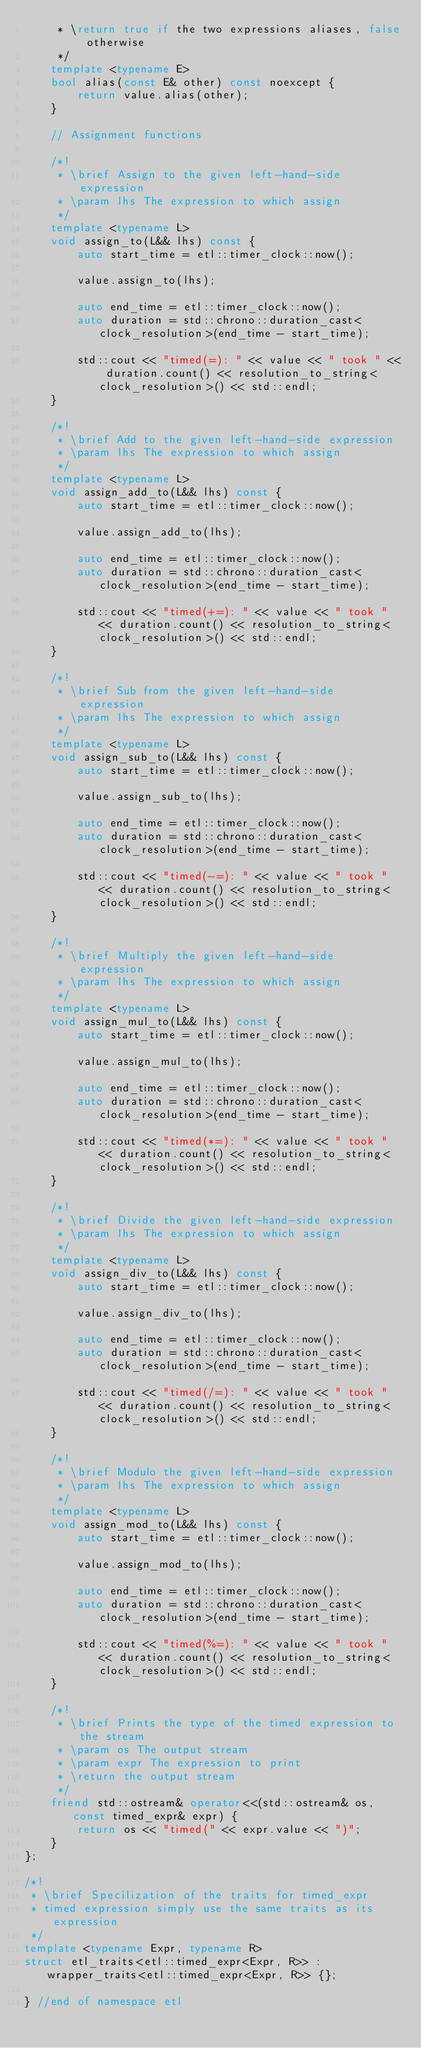Convert code to text. <code><loc_0><loc_0><loc_500><loc_500><_C++_>     * \return true if the two expressions aliases, false otherwise
     */
    template <typename E>
    bool alias(const E& other) const noexcept {
        return value.alias(other);
    }

    // Assignment functions

    /*!
     * \brief Assign to the given left-hand-side expression
     * \param lhs The expression to which assign
     */
    template <typename L>
    void assign_to(L&& lhs) const {
        auto start_time = etl::timer_clock::now();

        value.assign_to(lhs);

        auto end_time = etl::timer_clock::now();
        auto duration = std::chrono::duration_cast<clock_resolution>(end_time - start_time);

        std::cout << "timed(=): " << value << " took " << duration.count() << resolution_to_string<clock_resolution>() << std::endl;
    }

    /*!
     * \brief Add to the given left-hand-side expression
     * \param lhs The expression to which assign
     */
    template <typename L>
    void assign_add_to(L&& lhs) const {
        auto start_time = etl::timer_clock::now();

        value.assign_add_to(lhs);

        auto end_time = etl::timer_clock::now();
        auto duration = std::chrono::duration_cast<clock_resolution>(end_time - start_time);

        std::cout << "timed(+=): " << value << " took " << duration.count() << resolution_to_string<clock_resolution>() << std::endl;
    }

    /*!
     * \brief Sub from the given left-hand-side expression
     * \param lhs The expression to which assign
     */
    template <typename L>
    void assign_sub_to(L&& lhs) const {
        auto start_time = etl::timer_clock::now();

        value.assign_sub_to(lhs);

        auto end_time = etl::timer_clock::now();
        auto duration = std::chrono::duration_cast<clock_resolution>(end_time - start_time);

        std::cout << "timed(-=): " << value << " took " << duration.count() << resolution_to_string<clock_resolution>() << std::endl;
    }

    /*!
     * \brief Multiply the given left-hand-side expression
     * \param lhs The expression to which assign
     */
    template <typename L>
    void assign_mul_to(L&& lhs) const {
        auto start_time = etl::timer_clock::now();

        value.assign_mul_to(lhs);

        auto end_time = etl::timer_clock::now();
        auto duration = std::chrono::duration_cast<clock_resolution>(end_time - start_time);

        std::cout << "timed(*=): " << value << " took " << duration.count() << resolution_to_string<clock_resolution>() << std::endl;
    }

    /*!
     * \brief Divide the given left-hand-side expression
     * \param lhs The expression to which assign
     */
    template <typename L>
    void assign_div_to(L&& lhs) const {
        auto start_time = etl::timer_clock::now();

        value.assign_div_to(lhs);

        auto end_time = etl::timer_clock::now();
        auto duration = std::chrono::duration_cast<clock_resolution>(end_time - start_time);

        std::cout << "timed(/=): " << value << " took " << duration.count() << resolution_to_string<clock_resolution>() << std::endl;
    }

    /*!
     * \brief Modulo the given left-hand-side expression
     * \param lhs The expression to which assign
     */
    template <typename L>
    void assign_mod_to(L&& lhs) const {
        auto start_time = etl::timer_clock::now();

        value.assign_mod_to(lhs);

        auto end_time = etl::timer_clock::now();
        auto duration = std::chrono::duration_cast<clock_resolution>(end_time - start_time);

        std::cout << "timed(%=): " << value << " took " << duration.count() << resolution_to_string<clock_resolution>() << std::endl;
    }

    /*!
     * \brief Prints the type of the timed expression to the stream
     * \param os The output stream
     * \param expr The expression to print
     * \return the output stream
     */
    friend std::ostream& operator<<(std::ostream& os, const timed_expr& expr) {
        return os << "timed(" << expr.value << ")";
    }
};

/*!
 * \brief Specilization of the traits for timed_expr
 * timed expression simply use the same traits as its expression
 */
template <typename Expr, typename R>
struct etl_traits<etl::timed_expr<Expr, R>> : wrapper_traits<etl::timed_expr<Expr, R>> {};

} //end of namespace etl
</code> 